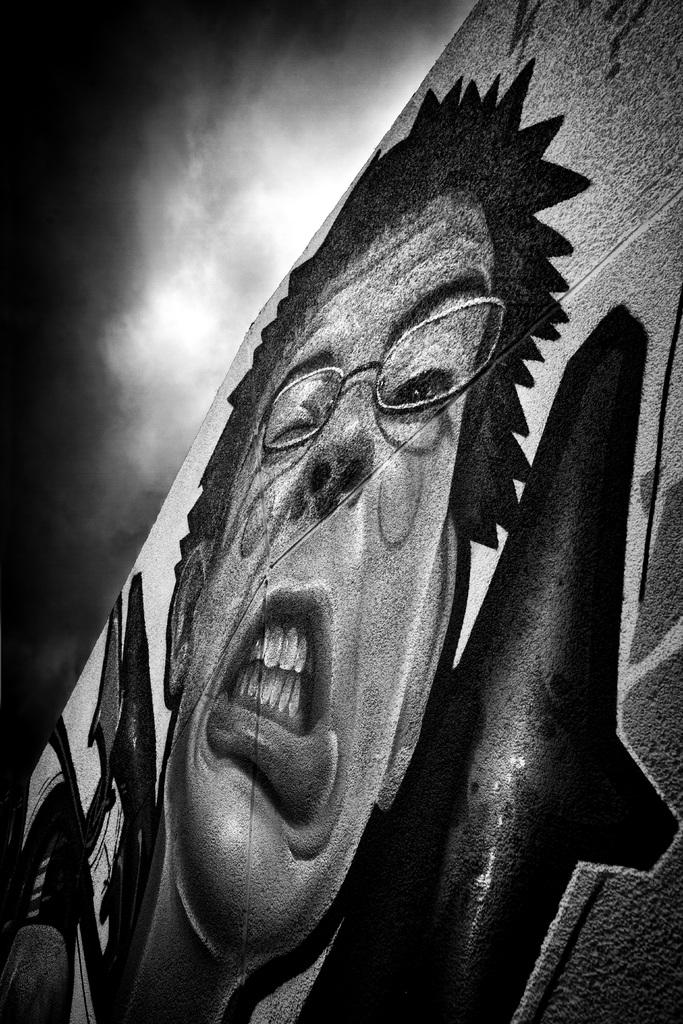What is depicted on the wall in the image? There is a painting of a person on the wall. What can be seen in the background of the image? The background of the image includes the sky. How many girls are playing in the waves in the image? There are no girls or waves present in the image; it features a painting of a person on the wall and a sky background. 